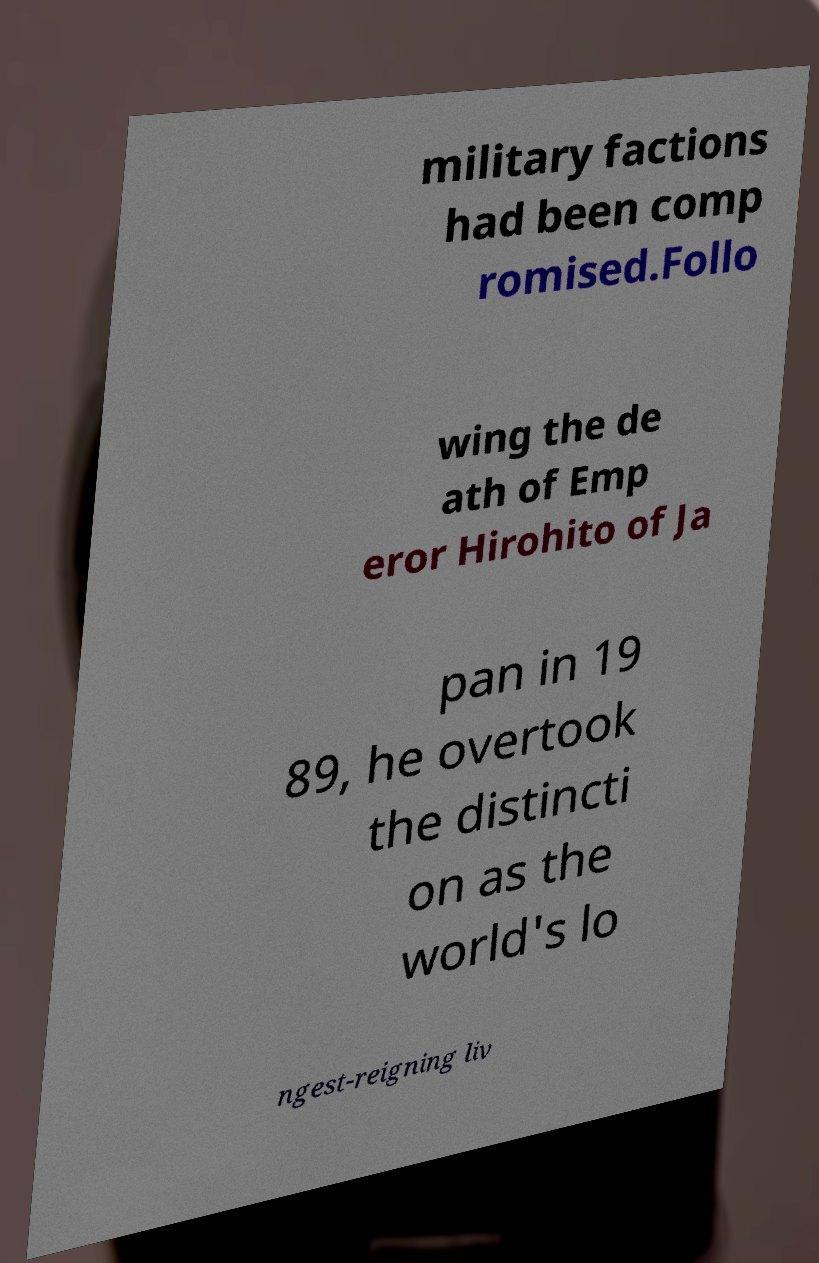Could you assist in decoding the text presented in this image and type it out clearly? military factions had been comp romised.Follo wing the de ath of Emp eror Hirohito of Ja pan in 19 89, he overtook the distincti on as the world's lo ngest-reigning liv 